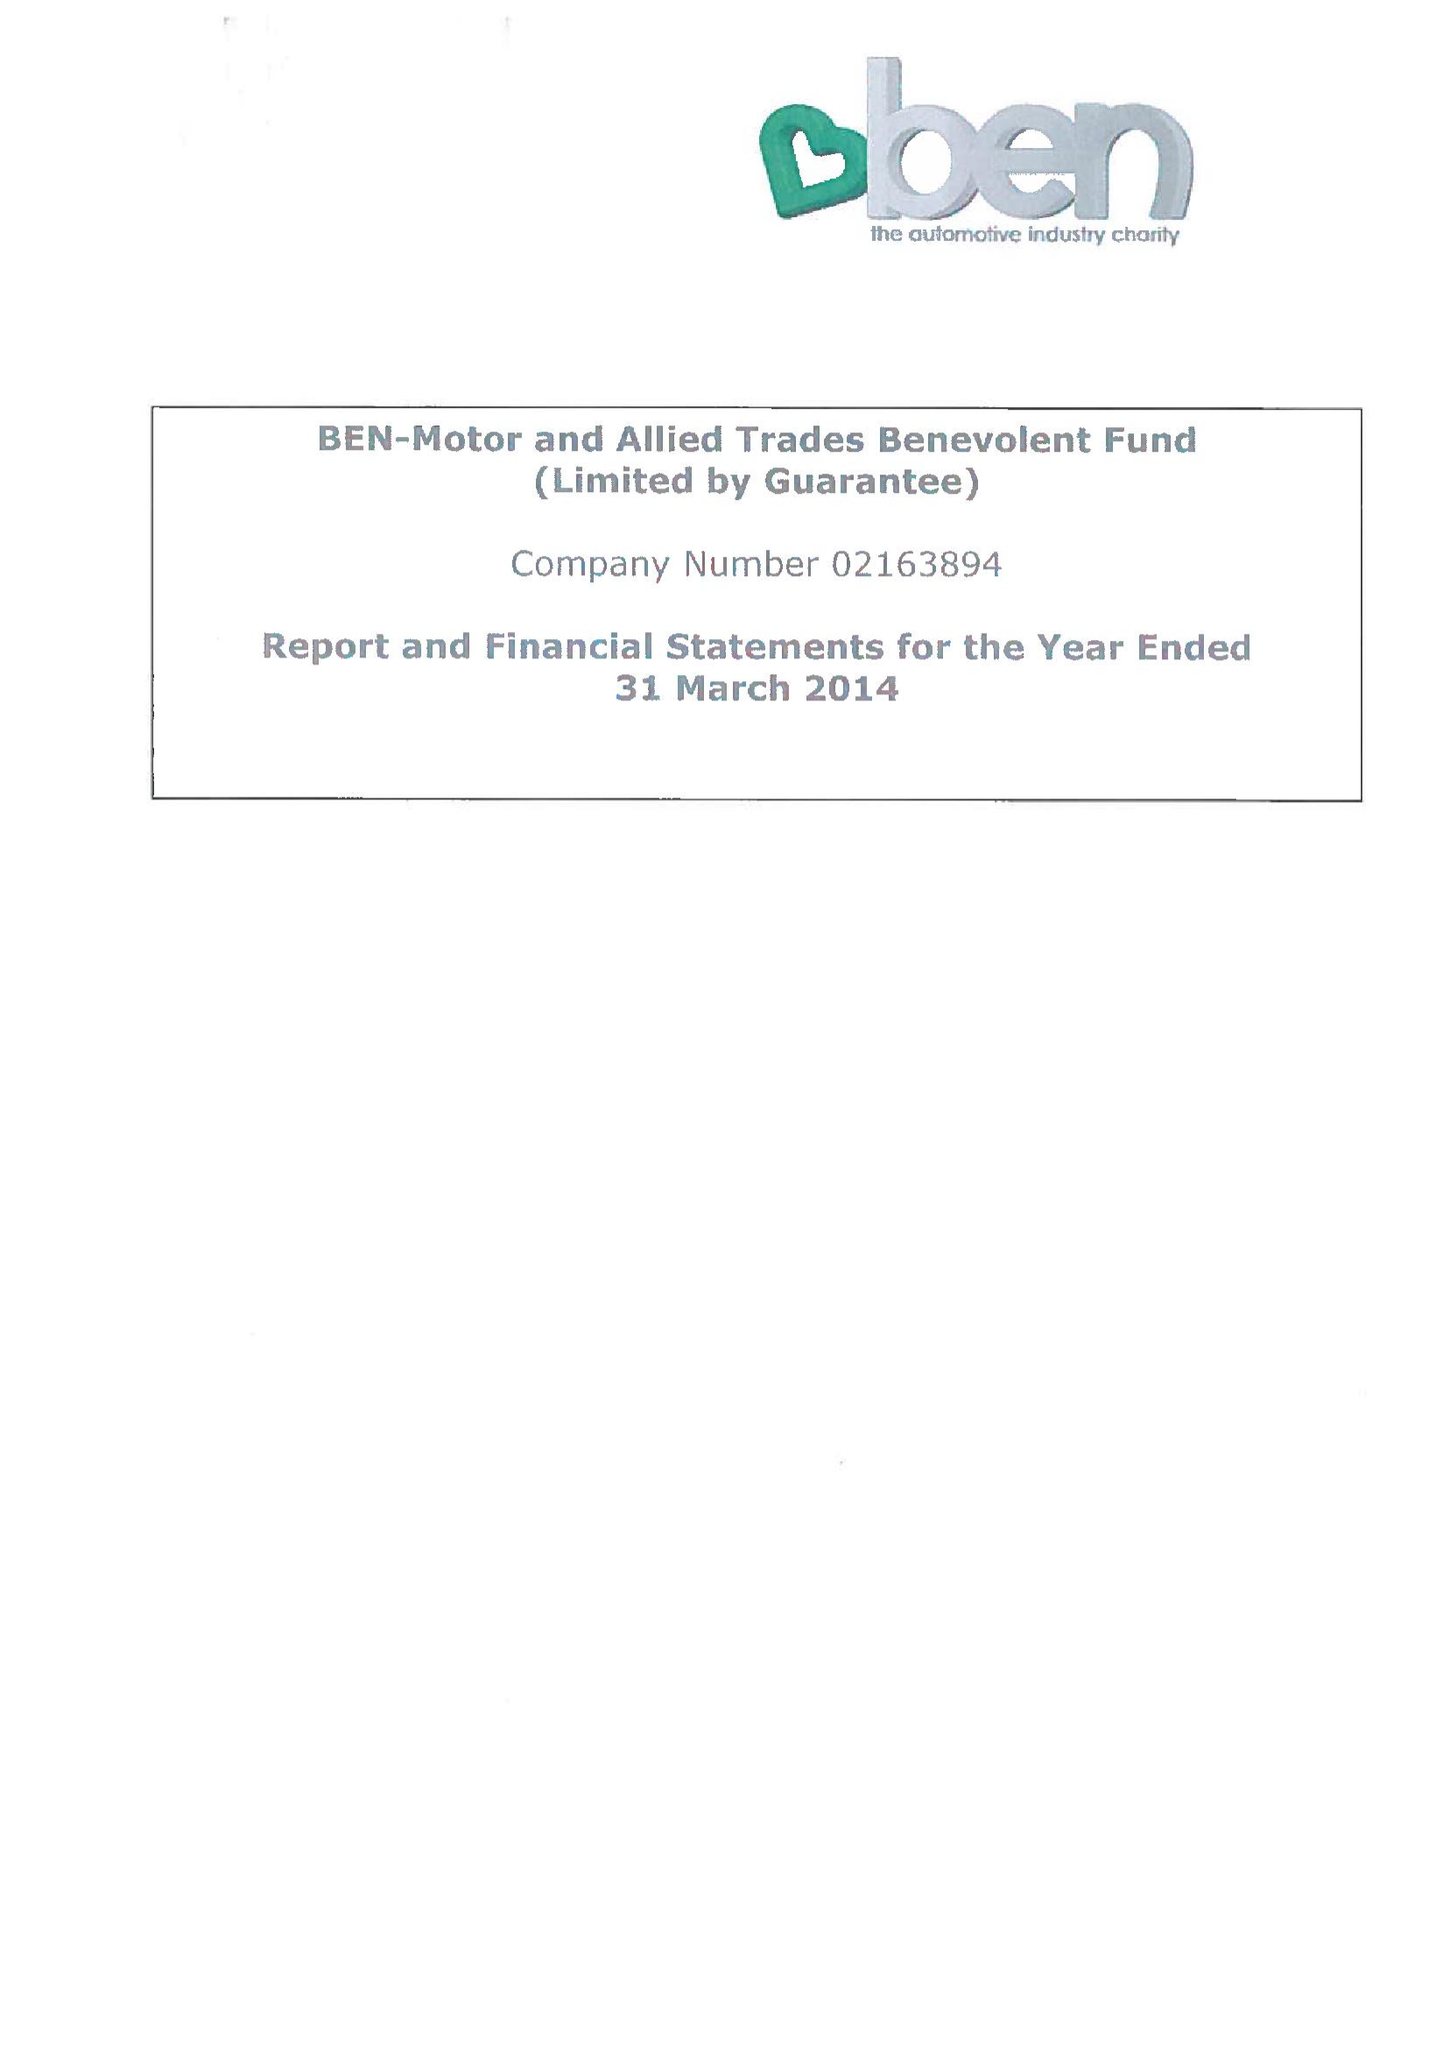What is the value for the address__post_town?
Answer the question using a single word or phrase. ASCOT 